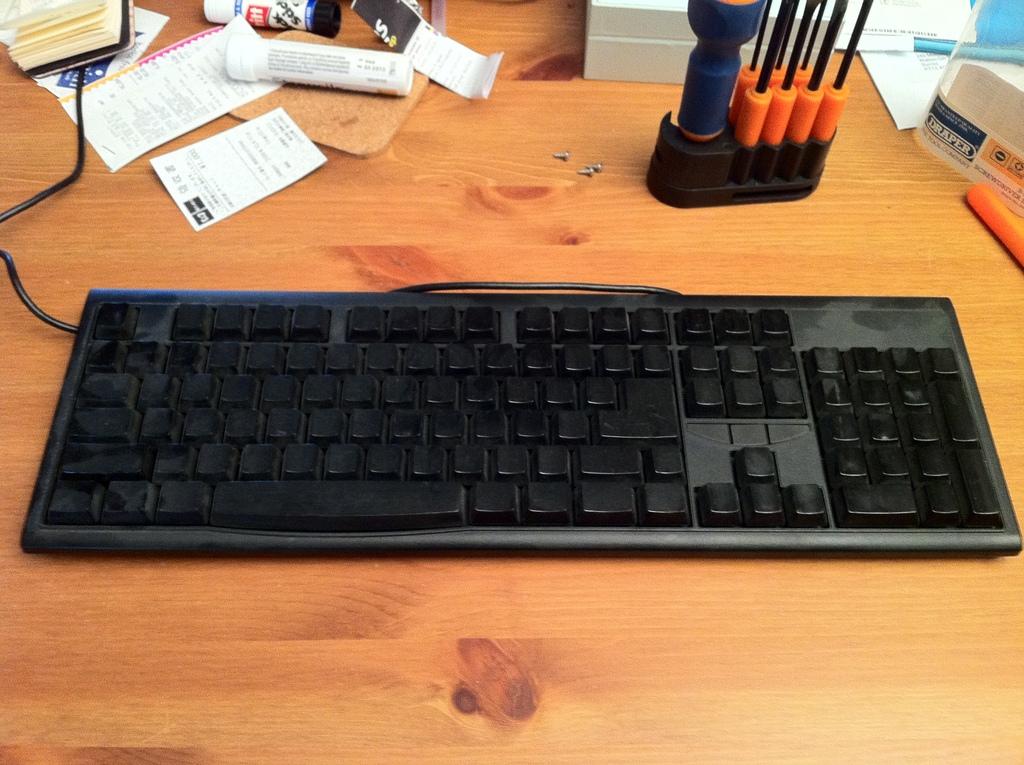What word is written inside a circle in white with a blue background on the right hand side?
Keep it short and to the point. Draper. 